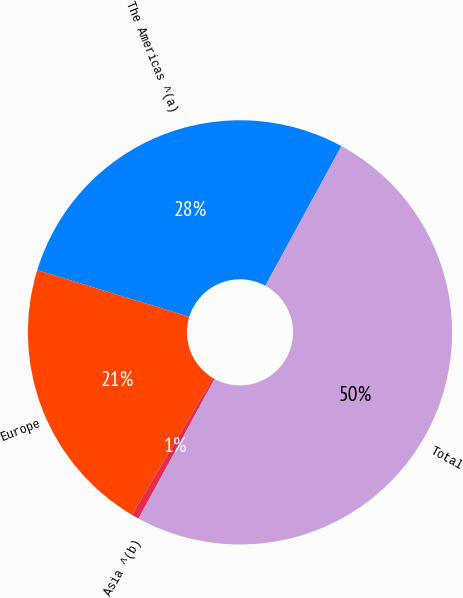Convert chart to OTSL. <chart><loc_0><loc_0><loc_500><loc_500><pie_chart><fcel>The Americas ^(a)<fcel>Europe<fcel>Asia ^(b)<fcel>Total<nl><fcel>28.2%<fcel>21.23%<fcel>0.57%<fcel>50.0%<nl></chart> 